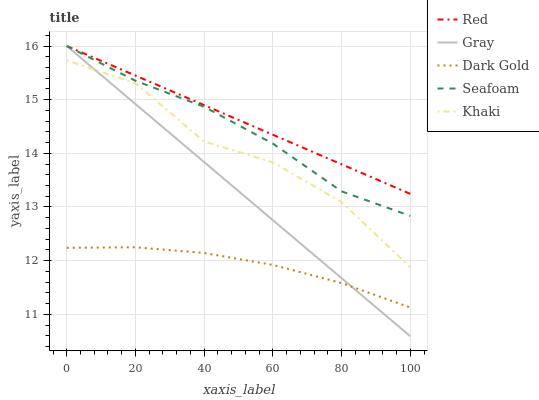Does Khaki have the minimum area under the curve?
Answer yes or no. No. Does Khaki have the maximum area under the curve?
Answer yes or no. No. Is Seafoam the smoothest?
Answer yes or no. No. Is Seafoam the roughest?
Answer yes or no. No. Does Khaki have the lowest value?
Answer yes or no. No. Does Khaki have the highest value?
Answer yes or no. No. Is Dark Gold less than Seafoam?
Answer yes or no. Yes. Is Khaki greater than Dark Gold?
Answer yes or no. Yes. Does Dark Gold intersect Seafoam?
Answer yes or no. No. 